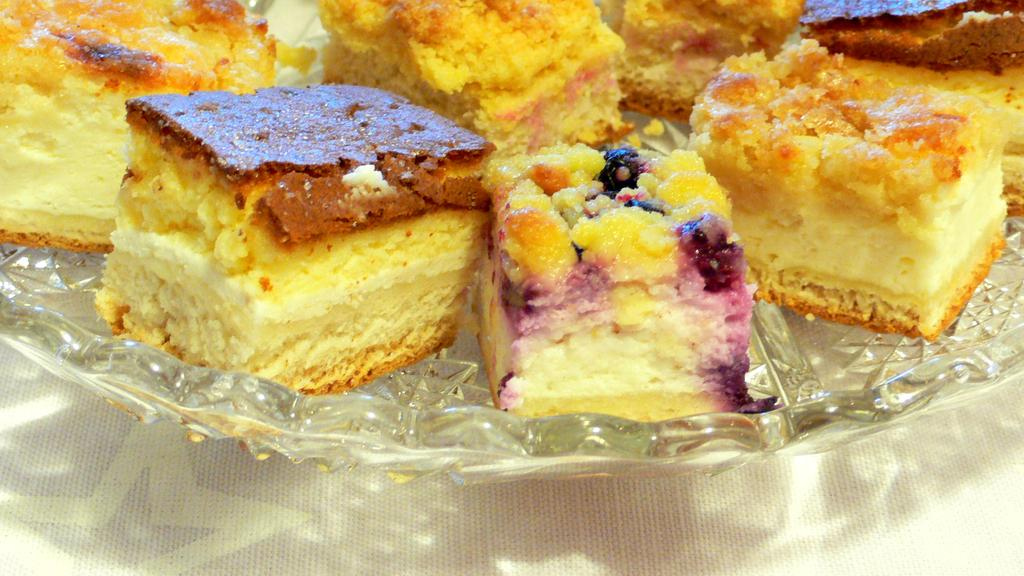What is on the glass plate in the image? There are pieces of cake on the plate. What type of surface is the plate resting on? The plate is on a white surface. How much water is in the tub in the image? There is no tub or water present in the image; it features a glass plate with pieces of cake on a white surface. 